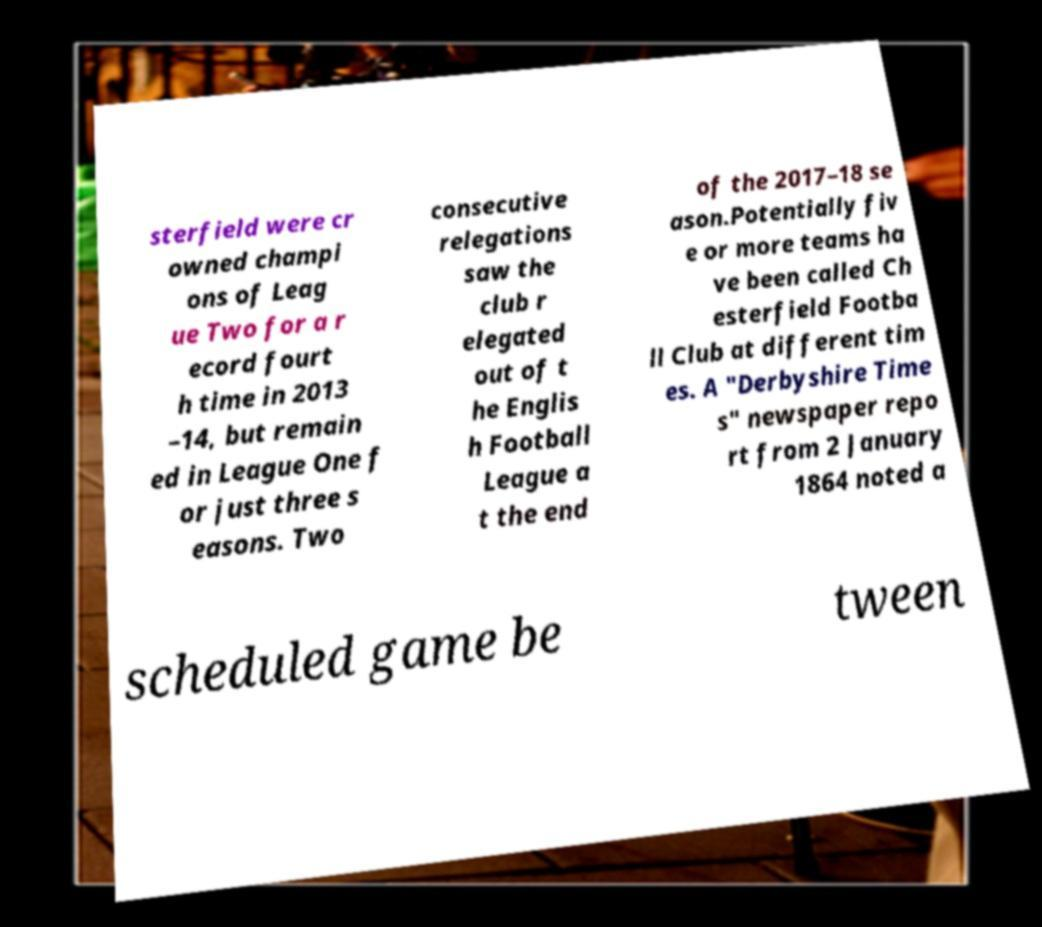Please identify and transcribe the text found in this image. sterfield were cr owned champi ons of Leag ue Two for a r ecord fourt h time in 2013 –14, but remain ed in League One f or just three s easons. Two consecutive relegations saw the club r elegated out of t he Englis h Football League a t the end of the 2017–18 se ason.Potentially fiv e or more teams ha ve been called Ch esterfield Footba ll Club at different tim es. A "Derbyshire Time s" newspaper repo rt from 2 January 1864 noted a scheduled game be tween 